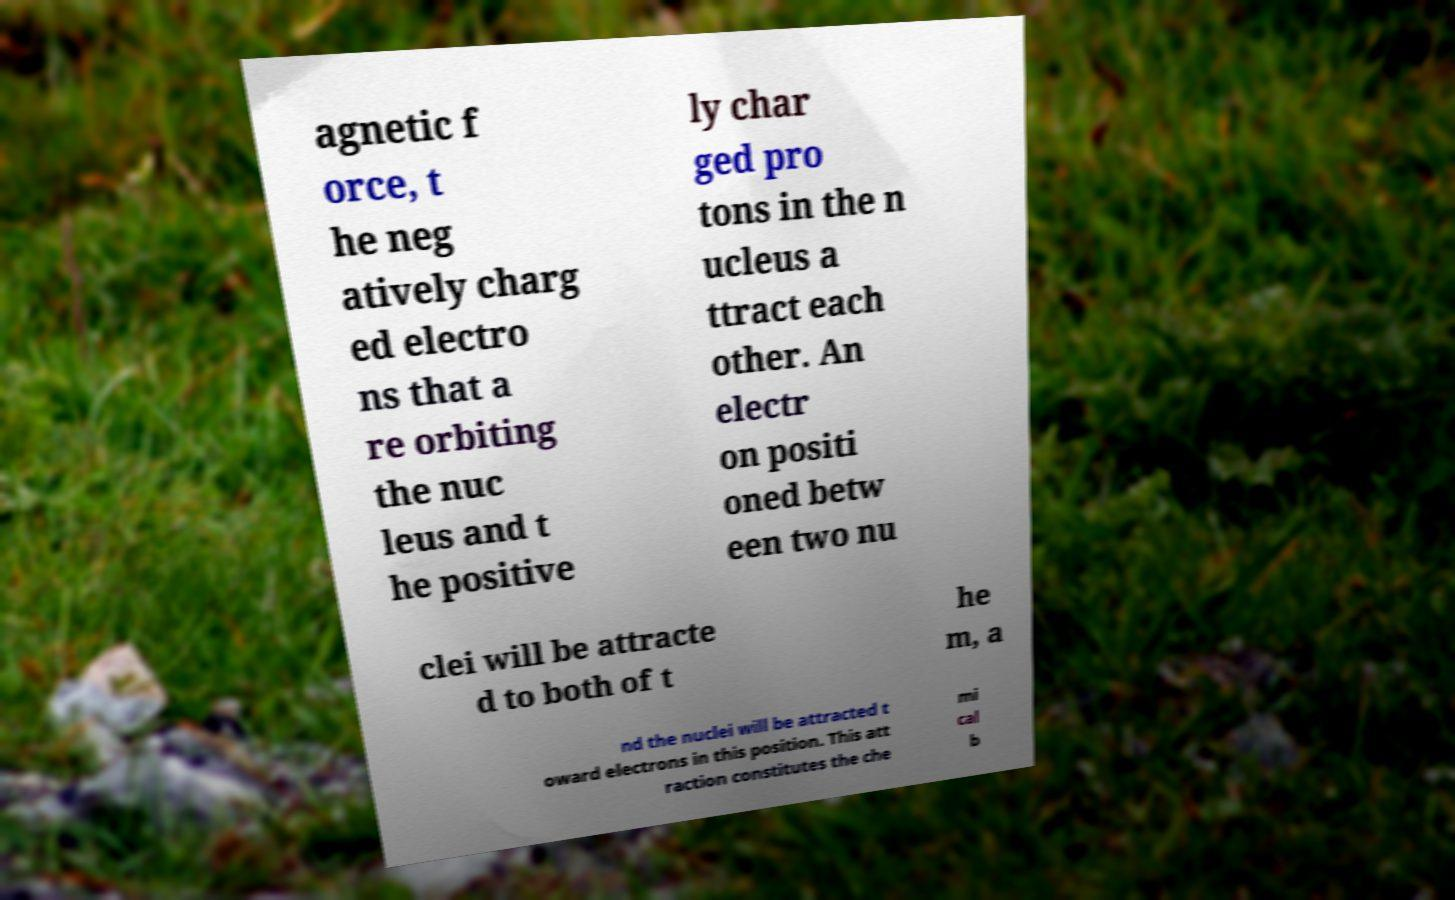Please identify and transcribe the text found in this image. agnetic f orce, t he neg atively charg ed electro ns that a re orbiting the nuc leus and t he positive ly char ged pro tons in the n ucleus a ttract each other. An electr on positi oned betw een two nu clei will be attracte d to both of t he m, a nd the nuclei will be attracted t oward electrons in this position. This att raction constitutes the che mi cal b 